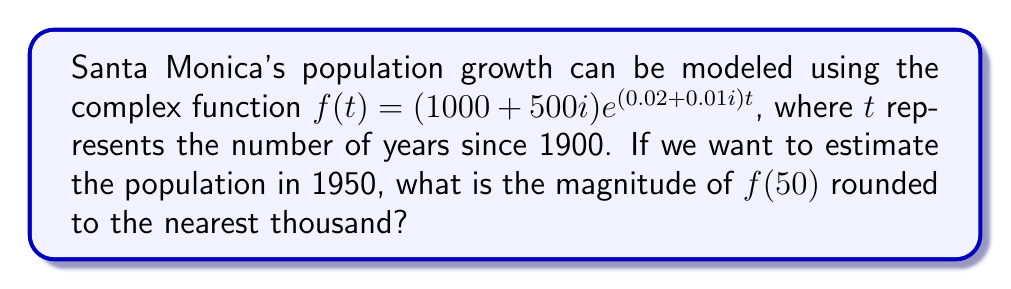Give your solution to this math problem. To solve this problem, we'll follow these steps:

1) We need to calculate $f(50)$ using the given function:
   $f(t) = (1000 + 500i)e^{(0.02 + 0.01i)t}$
   $f(50) = (1000 + 500i)e^{(0.02 + 0.01i)50}$

2) Let's simplify the exponent:
   $(0.02 + 0.01i)50 = 1 + 0.5i$

3) Now we have:
   $f(50) = (1000 + 500i)e^{1 + 0.5i}$

4) We can rewrite this in polar form:
   $f(50) = (1000 + 500i)(e \cdot e^{0.5i})$

5) The magnitude of a complex number in the form $a + bi$ is given by $\sqrt{a^2 + b^2}$. 
   For $(1000 + 500i)$, this is $\sqrt{1000^2 + 500^2} \approx 1118.03$

6) The magnitude of $e^{1 + 0.5i}$ is simply $e^1 \approx 2.71828$

7) The magnitude of the product is the product of the magnitudes:
   $|f(50)| = 1118.03 \cdot 2.71828 \approx 3039.17$

8) Rounding to the nearest thousand gives us 3,000.
Answer: 3,000 